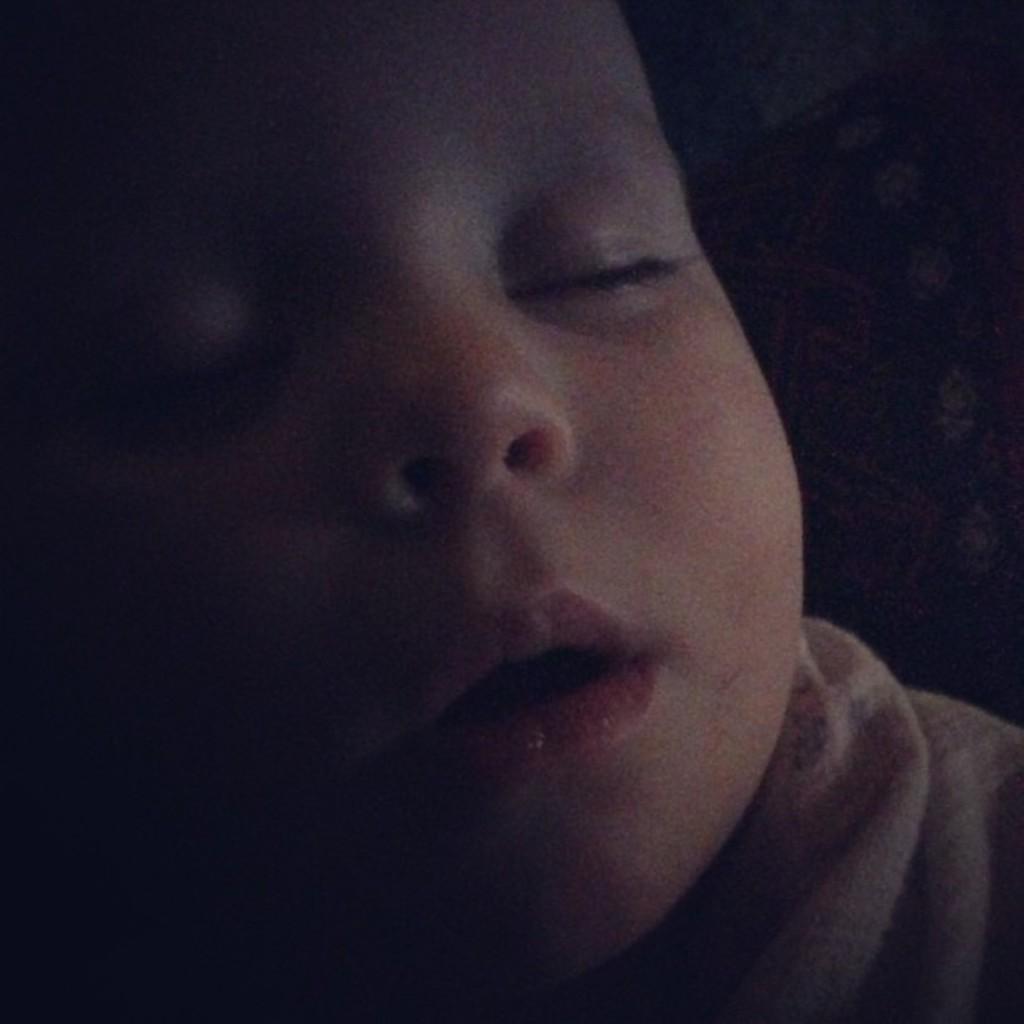Can you describe this image briefly? In this image we can see a kid. There is a dark background. 